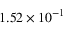Convert formula to latex. <formula><loc_0><loc_0><loc_500><loc_500>1 . 5 2 \times 1 0 ^ { - 1 }</formula> 